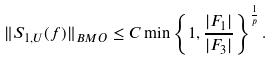Convert formula to latex. <formula><loc_0><loc_0><loc_500><loc_500>\| S _ { 1 , U } ( f ) \| _ { B M O } \leq C \min \left \{ 1 , \frac { | F _ { 1 } | } { | F _ { 3 } | } \right \} ^ { \frac { 1 } { p } } .</formula> 